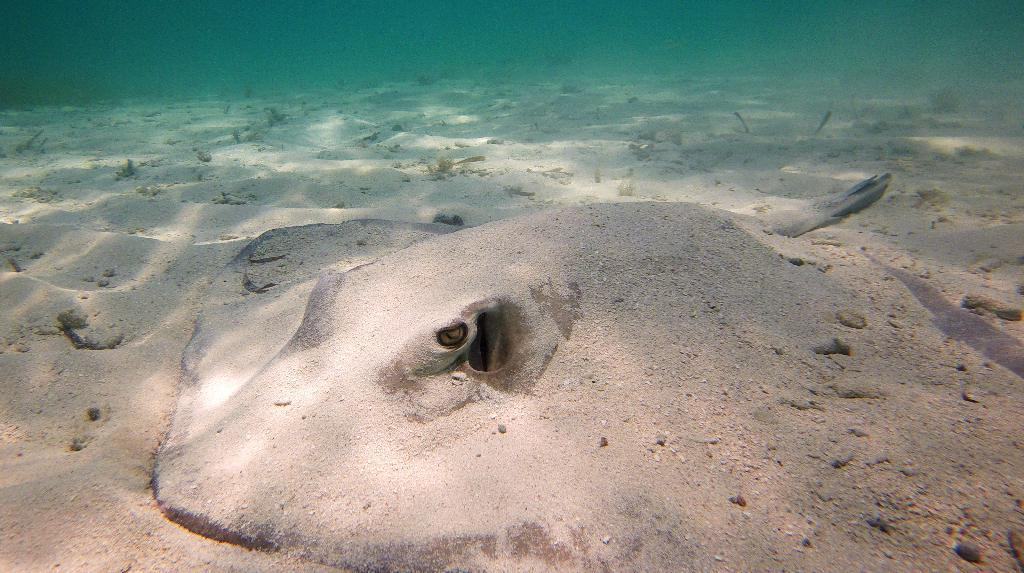What type of animal can be seen in the image? There is an aquatic animal in the image. Where is the image set? The image is set in an ocean. What is visible at the bottom of the image? There is sand at the bottom of the image. What is visible at the top of the image? There is water visible at the top of the image. How many ants can be seen crawling on the visitor's finger in the image? There are no ants or visitors present in the image; it features an aquatic animal in an ocean setting. 